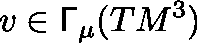Convert formula to latex. <formula><loc_0><loc_0><loc_500><loc_500>v \in \Gamma _ { \mu } ( T M ^ { 3 } )</formula> 